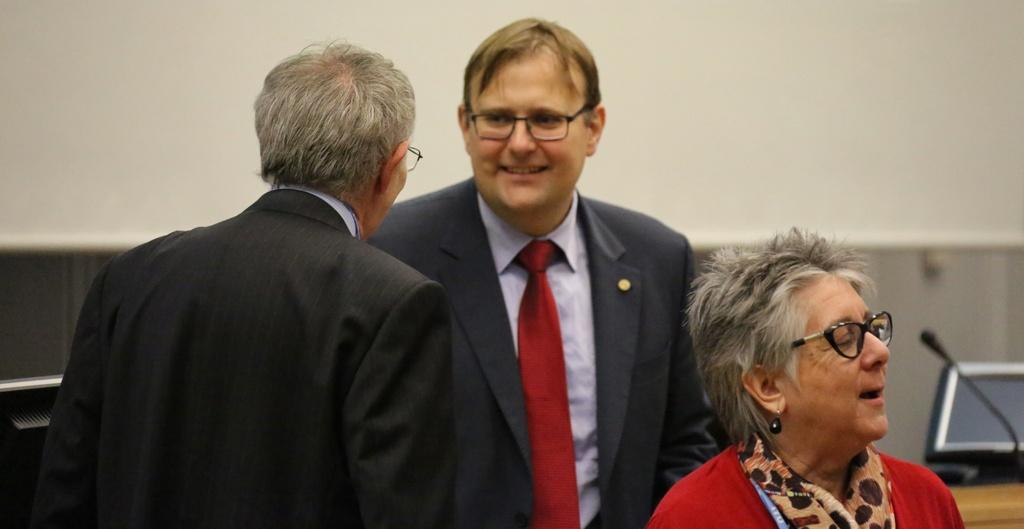How many people are in the image? There are three people in the image. Where are the people located in the image? The people are on a path in the image. What electronic devices can be seen in the image? Monitors and a microphone are visible in the image. What is in the background of the image? There is a wall in the background of the image. What type of milk is being poured into the microphone in the image? There is no milk present in the image, and the microphone is not being used for pouring any liquid. 